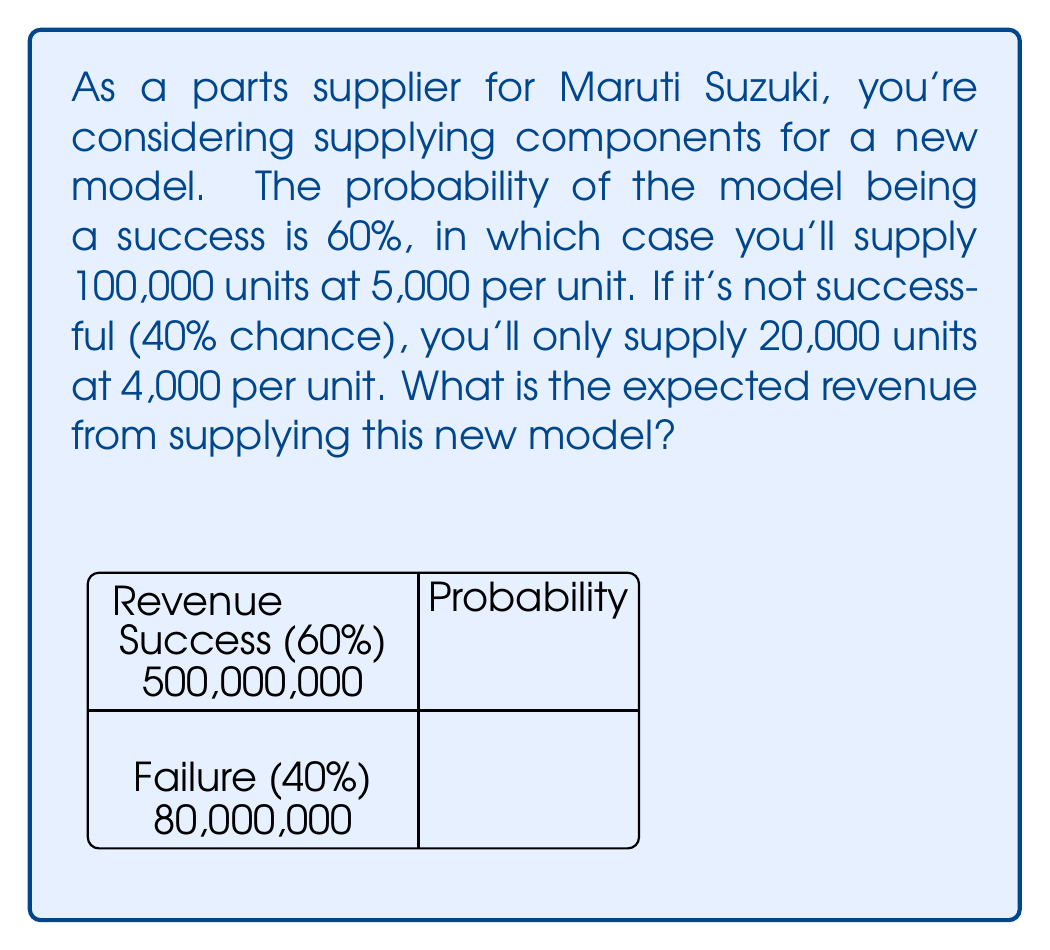Can you solve this math problem? To calculate the expected revenue, we need to consider both scenarios and their probabilities:

1) Success scenario:
   - Probability: $P(\text{success}) = 60\% = 0.6$
   - Revenue: $R(\text{success}) = 100,000 \times ₹5,000 = ₹500,000,000$

2) Failure scenario:
   - Probability: $P(\text{failure}) = 40\% = 0.4$
   - Revenue: $R(\text{failure}) = 20,000 \times ₹4,000 = ₹80,000,000$

The expected revenue is calculated using the formula:

$$E(\text{Revenue}) = P(\text{success}) \times R(\text{success}) + P(\text{failure}) \times R(\text{failure})$$

Substituting the values:

$$\begin{align}
E(\text{Revenue}) &= 0.6 \times ₹500,000,000 + 0.4 \times ₹80,000,000 \\
&= ₹300,000,000 + ₹32,000,000 \\
&= ₹332,000,000
\end{align}$$

Therefore, the expected revenue from supplying components for this new Maruti Suzuki model is ₹332,000,000.
Answer: ₹332,000,000 